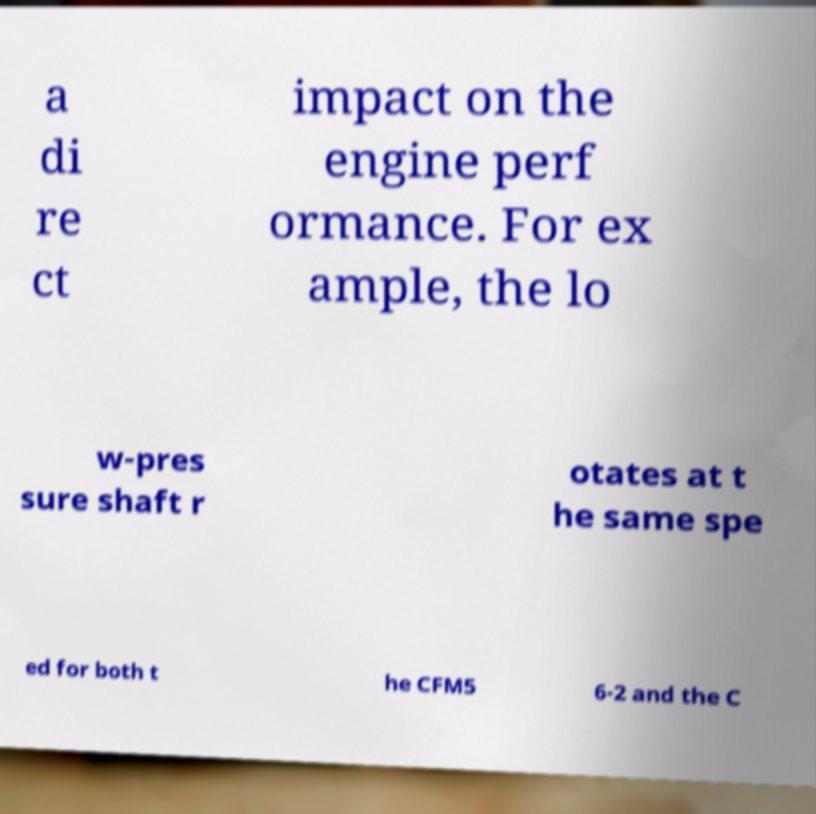Could you assist in decoding the text presented in this image and type it out clearly? a di re ct impact on the engine perf ormance. For ex ample, the lo w-pres sure shaft r otates at t he same spe ed for both t he CFM5 6-2 and the C 